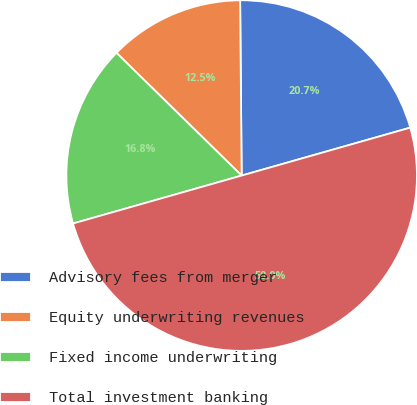Convert chart to OTSL. <chart><loc_0><loc_0><loc_500><loc_500><pie_chart><fcel>Advisory fees from merger<fcel>Equity underwriting revenues<fcel>Fixed income underwriting<fcel>Total investment banking<nl><fcel>20.73%<fcel>12.52%<fcel>16.75%<fcel>50.0%<nl></chart> 